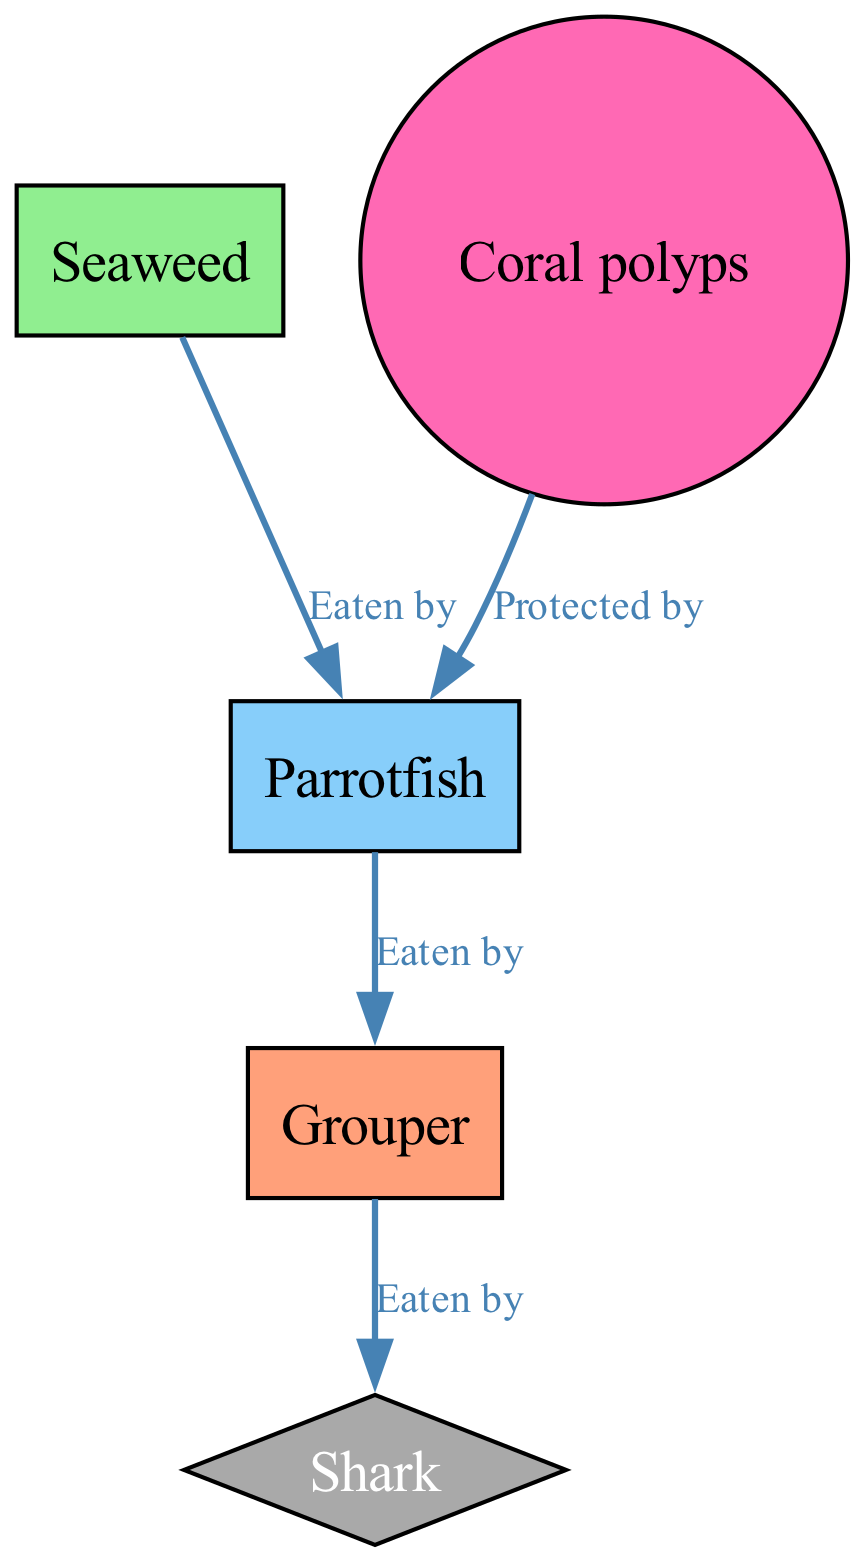What is the starting point of the food chain? The food chain starts with "Seaweed" which is the primary producer in the ecosystem of the coral reef.
Answer: Seaweed How many nodes are in the diagram? The diagram contains five nodes: Seaweed, Parrotfish, Grouper, Shark, and Coral polyps.
Answer: Five Who eats the Parrotfish? The Parrotfish is eaten by the Grouper, as indicated by the edge labeling "Eaten by" connecting these two nodes.
Answer: Grouper Which organism is protected by Coral polyps? The Coral polyps protect the Parrotfish, as shown by the edge labeled "Protected by" pointing from Coral polyps to Parrotfish.
Answer: Parrotfish What is the relationship between Grouper and Shark? The Grouper is eaten by the Shark, denoted by the edge indicating "Eaten by" from Grouper to Shark.
Answer: Eaten by If overfishing reduces the Shark population, what happens to the Grouper population? Reducing the Shark population would likely increase the Grouper population, as there would be less predation, allowing more Grouper to survive and thrive.
Answer: Increase How does the seaweed population relate to the Parrotfish? The Seaweed is consumed by the Parrotfish, which indicates that an increase in seaweed supports the Parrotfish's sustenance.
Answer: Eaten by What impact would overfishing have on coral reefs based on this diagram? Overfishing affects the top predator (Shark), leading to an imbalance where the Grouper population grows unchecked, which can decrease the Parrotfish population, ultimately harming coral polyps and the overall health of the reef.
Answer: Negative impact Is there a node that has a defensive relationship, and if so, what is it? Yes, Coral polyps have a defensive relationship with Parrotfish, providing protection as indicated in the diagram.
Answer: Yes, Coral polyps 